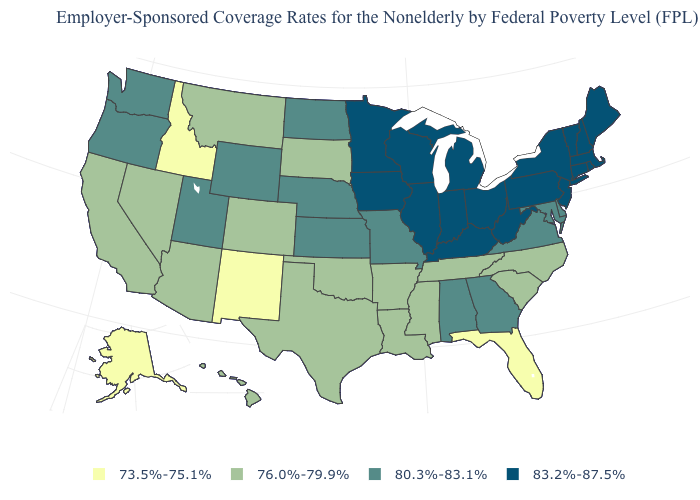Name the states that have a value in the range 76.0%-79.9%?
Keep it brief. Arizona, Arkansas, California, Colorado, Hawaii, Louisiana, Mississippi, Montana, Nevada, North Carolina, Oklahoma, South Carolina, South Dakota, Tennessee, Texas. Name the states that have a value in the range 73.5%-75.1%?
Be succinct. Alaska, Florida, Idaho, New Mexico. What is the value of Nebraska?
Give a very brief answer. 80.3%-83.1%. Does Rhode Island have the highest value in the USA?
Keep it brief. Yes. Does Florida have the lowest value in the South?
Answer briefly. Yes. What is the value of Oregon?
Write a very short answer. 80.3%-83.1%. Does Missouri have a higher value than Mississippi?
Keep it brief. Yes. Among the states that border Iowa , does Wisconsin have the highest value?
Be succinct. Yes. Among the states that border New Jersey , which have the highest value?
Quick response, please. New York, Pennsylvania. What is the value of Connecticut?
Keep it brief. 83.2%-87.5%. What is the value of Massachusetts?
Short answer required. 83.2%-87.5%. What is the value of New Mexico?
Be succinct. 73.5%-75.1%. Does Vermont have the same value as New Jersey?
Concise answer only. Yes. What is the value of Michigan?
Write a very short answer. 83.2%-87.5%. Among the states that border South Carolina , does Georgia have the lowest value?
Be succinct. No. 